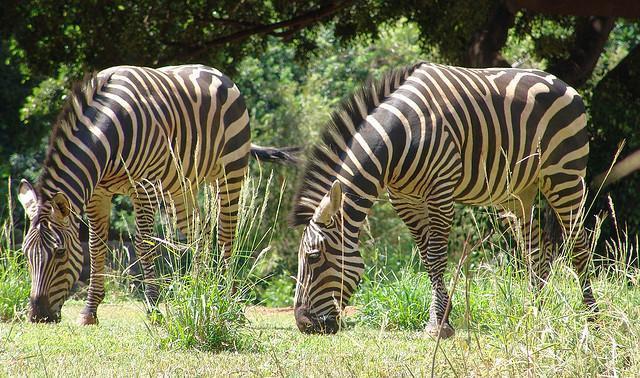How many animals are shown?
Give a very brief answer. 2. How many animals are there?
Give a very brief answer. 2. How many zebras in the picture?
Give a very brief answer. 2. How many zebras are in the photo?
Give a very brief answer. 2. 